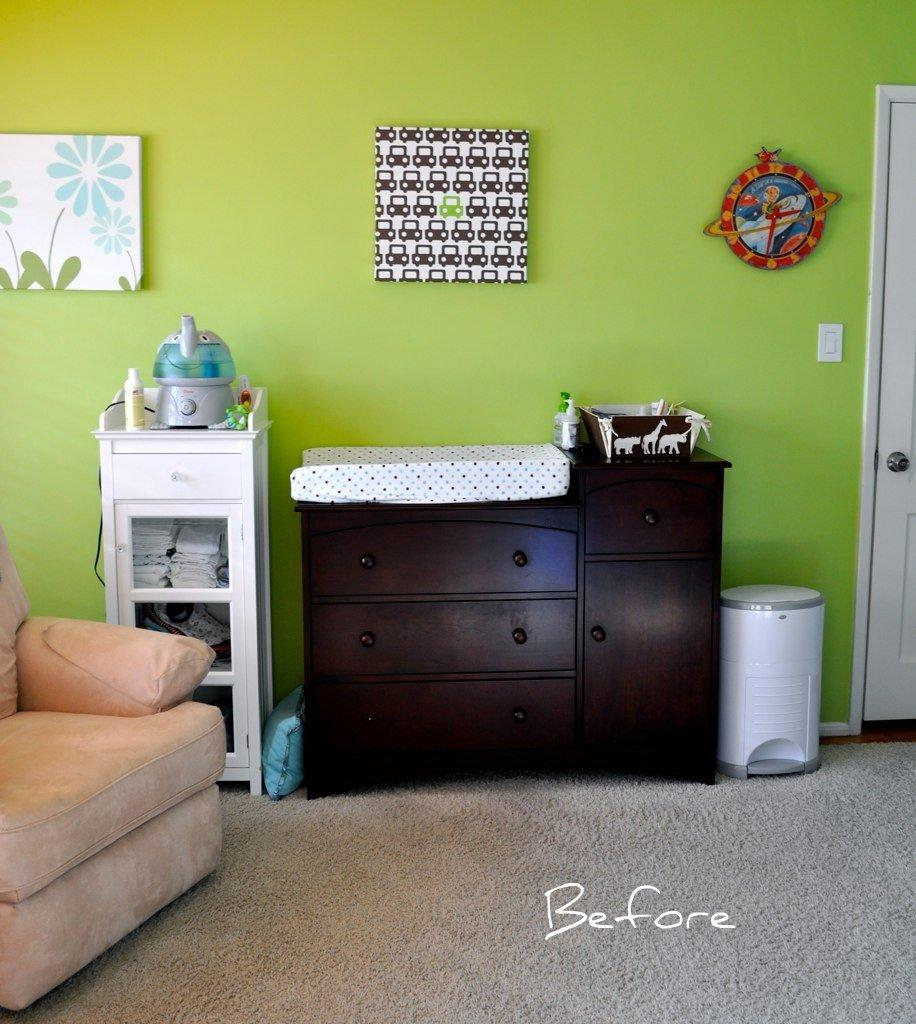<image>
Give a short and clear explanation of the subsequent image. A before picture of a baby's nursery room. 